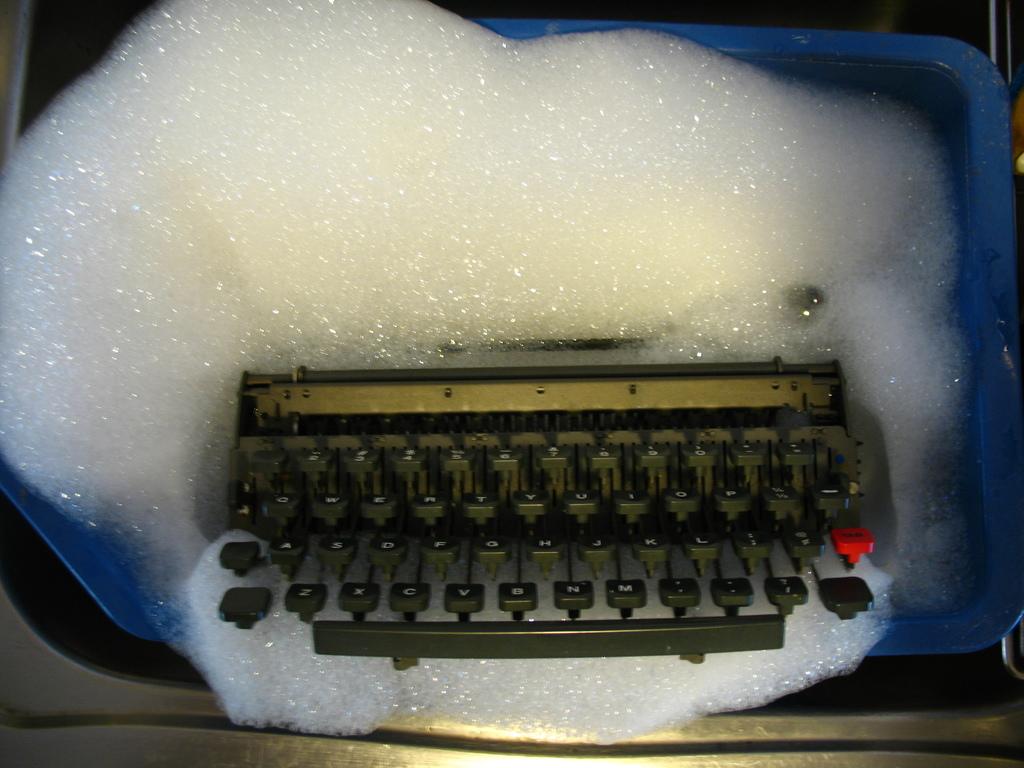What is the white stuff?
Make the answer very short. Answering does not require reading text in the image. 